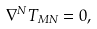<formula> <loc_0><loc_0><loc_500><loc_500>\nabla ^ { N } T _ { M N } = 0 ,</formula> 